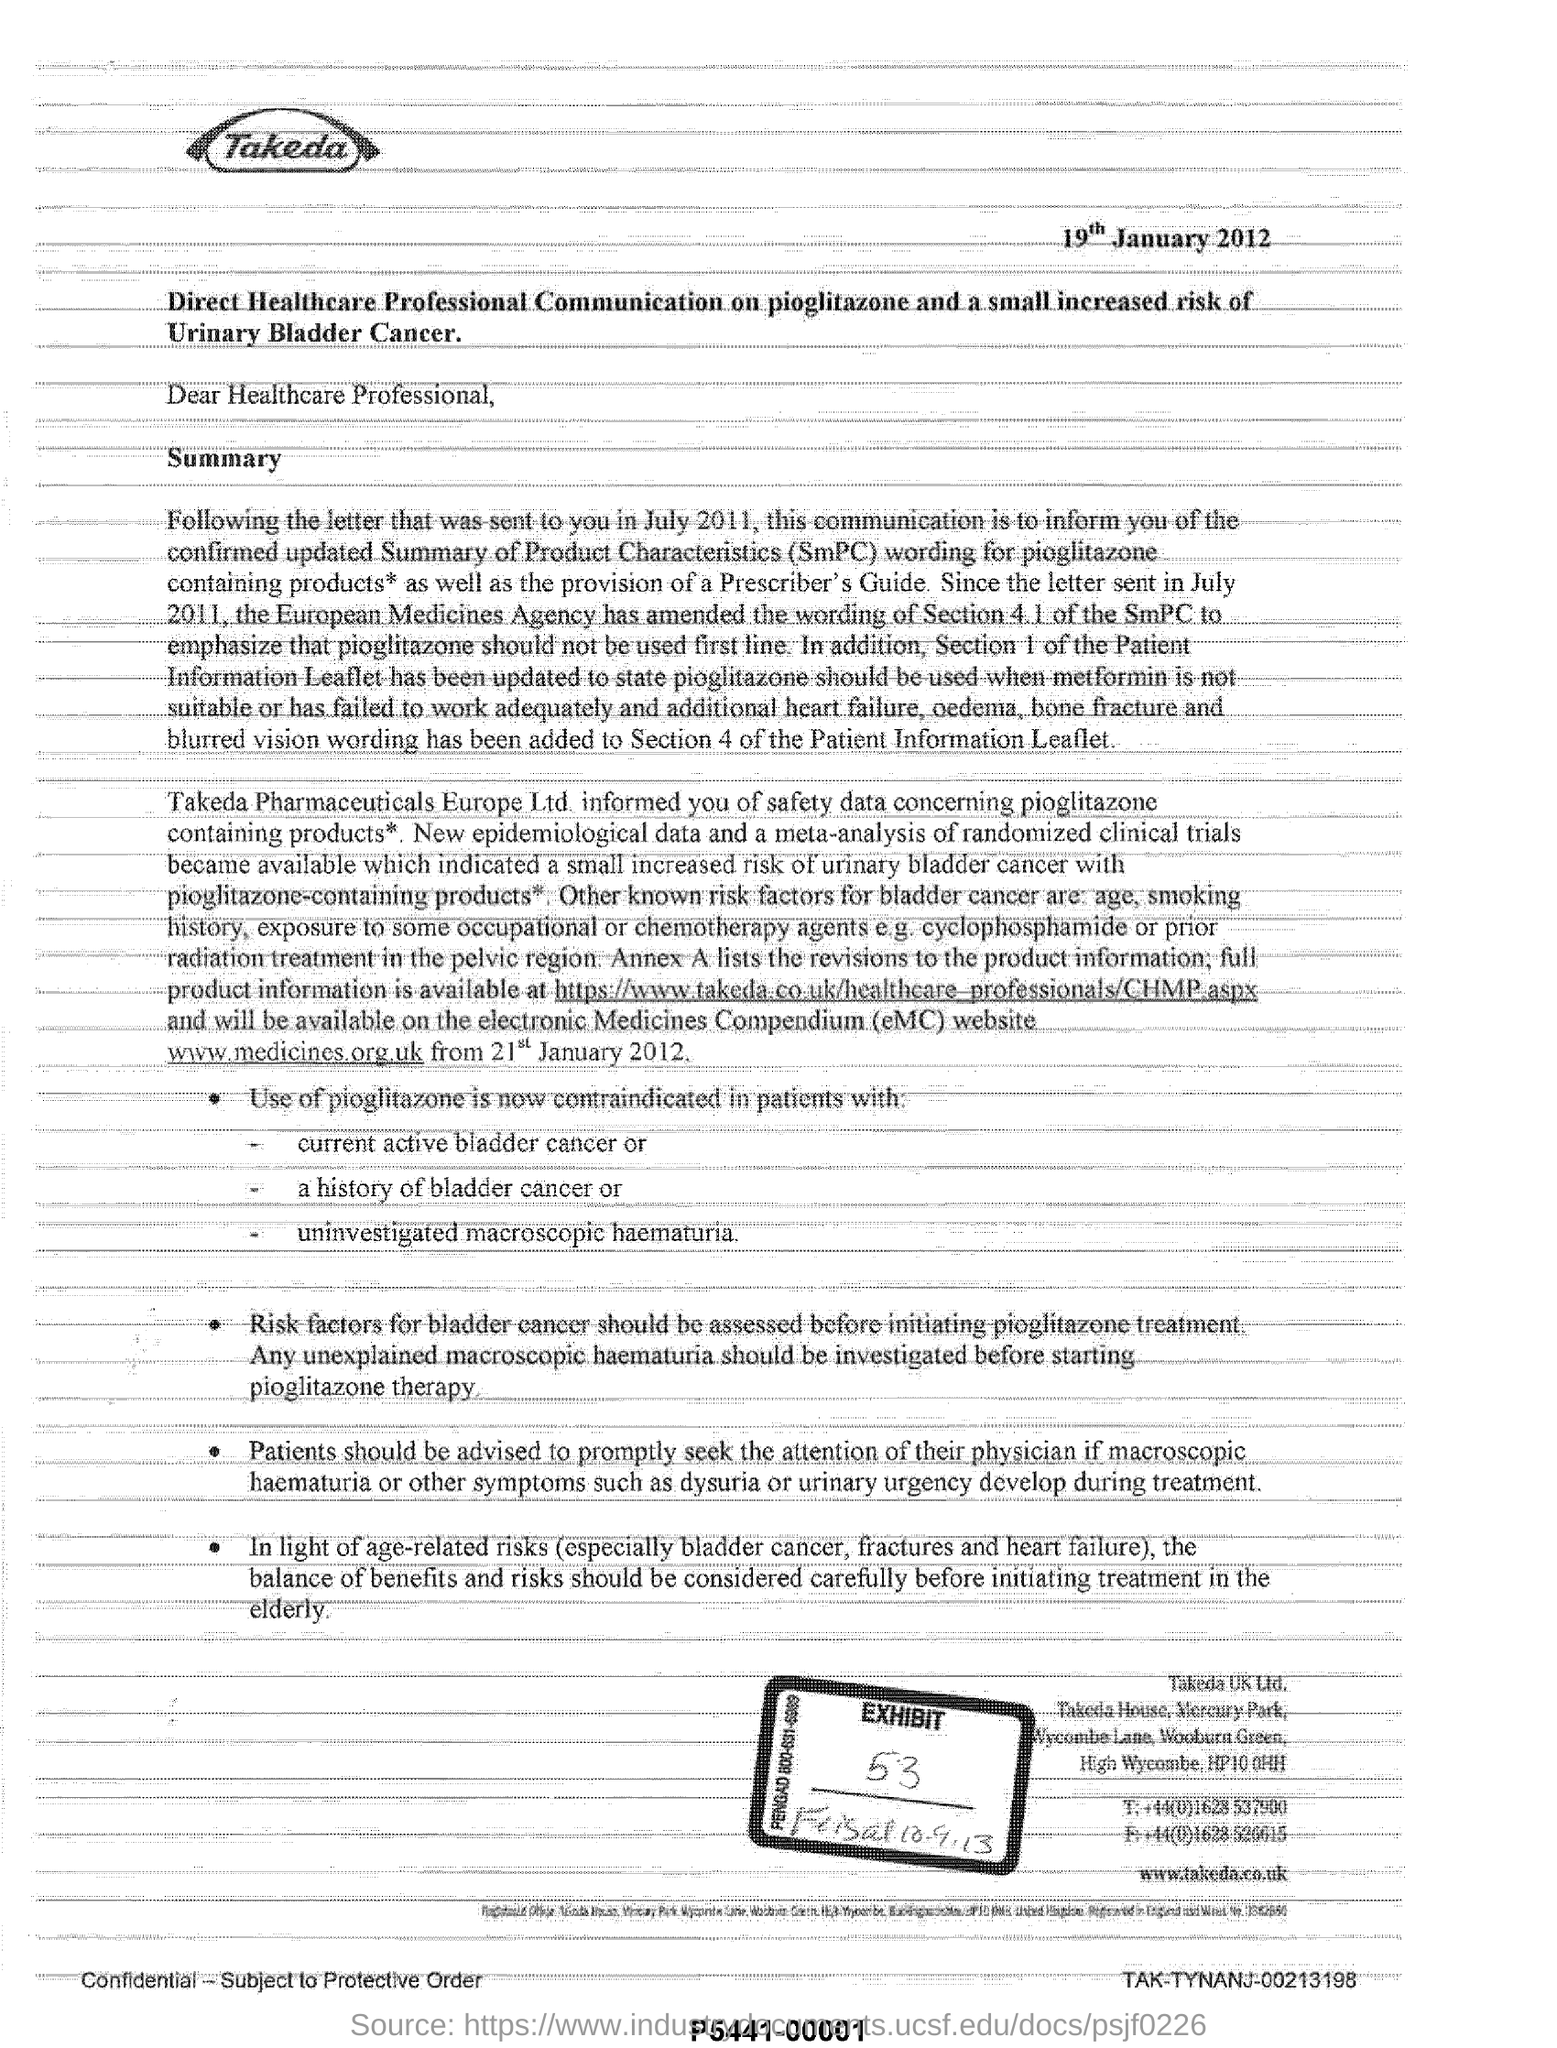What is the word written in bold on the top of the document?
Provide a short and direct response. Takeda. What is the date mentioned?
Provide a short and direct response. 19th January 2012. To whom was this letter written?
Your answer should be compact. Healthcare Professional. 